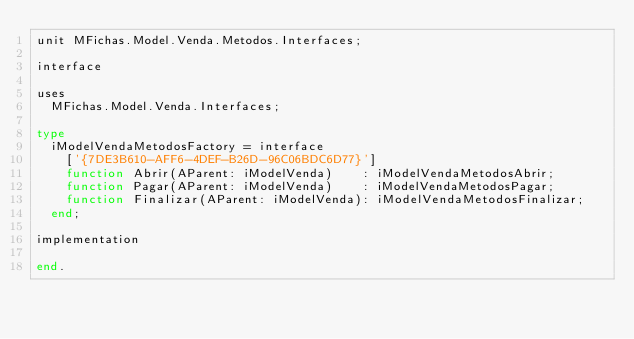Convert code to text. <code><loc_0><loc_0><loc_500><loc_500><_Pascal_>unit MFichas.Model.Venda.Metodos.Interfaces;

interface

uses
  MFichas.Model.Venda.Interfaces;

type
  iModelVendaMetodosFactory = interface
    ['{7DE3B610-AFF6-4DEF-B26D-96C06BDC6D77}']
    function Abrir(AParent: iModelVenda)    : iModelVendaMetodosAbrir;
    function Pagar(AParent: iModelVenda)    : iModelVendaMetodosPagar;
    function Finalizar(AParent: iModelVenda): iModelVendaMetodosFinalizar;
  end;

implementation

end.
</code> 